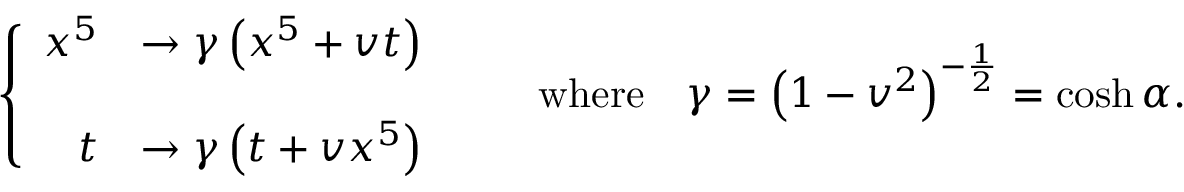Convert formula to latex. <formula><loc_0><loc_0><loc_500><loc_500>\left \{ \begin{array} { r l } { { x ^ { 5 } } } & { { \rightarrow \gamma \left ( x ^ { 5 } + v t \right ) } } \\ { t } & { { \rightarrow \gamma \left ( t + v x ^ { 5 } \right ) } } \end{array} \quad w h e r e \quad \gamma = \left ( 1 - v ^ { 2 } \right ) ^ { - { \frac { 1 } { 2 } } } = \cosh \alpha .</formula> 